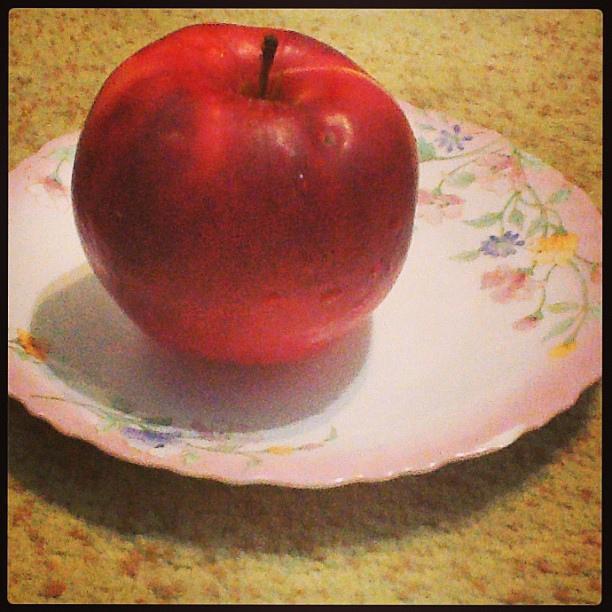How many beds can be seen?
Give a very brief answer. 0. 